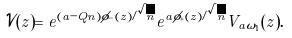<formula> <loc_0><loc_0><loc_500><loc_500>\mathcal { V } ( z ) = e ^ { ( a - Q n ) \phi _ { - } ( z ) / \sqrt { n } } e ^ { a \phi _ { + } ( z ) / \sqrt { n } } V _ { a \omega _ { 1 } } ( z ) .</formula> 